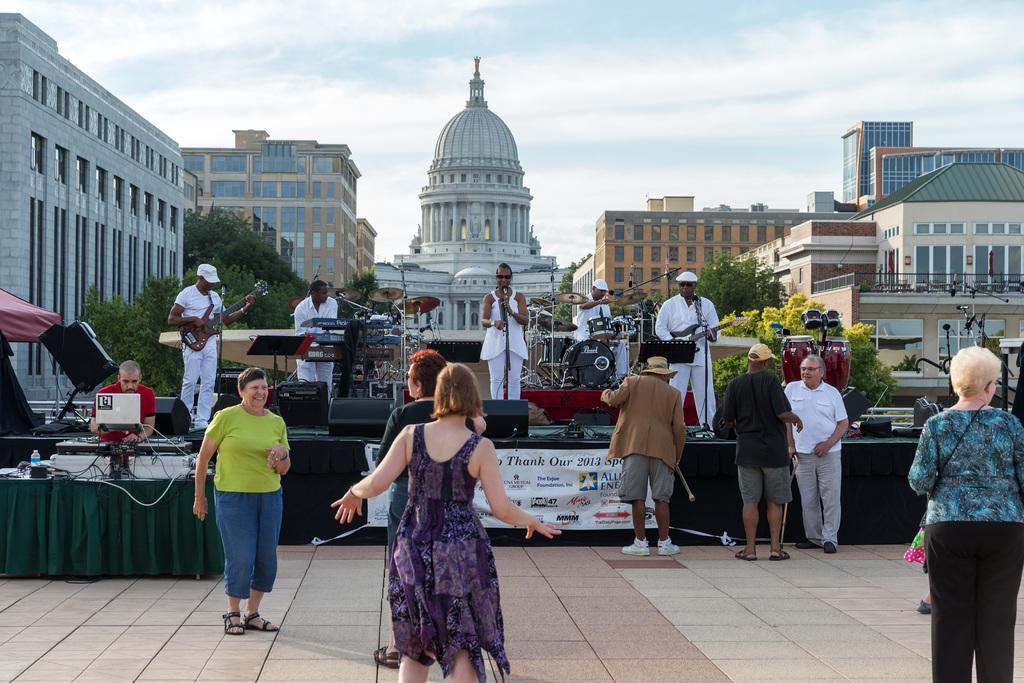Describe this image in one or two sentences. At the bottom of this image, there are persons in different color dresses on the floor, on which there is a person in red color T-shirt, standing in front of the table, on which there are musical instruments, a laptop, a bottle and other objects arranged. In the background, there are persons in the white colored dresses, standing on the stage, on which there are speakers and musical instruments arranged, there are buildings, trees and there are clouds in the blue sky. 